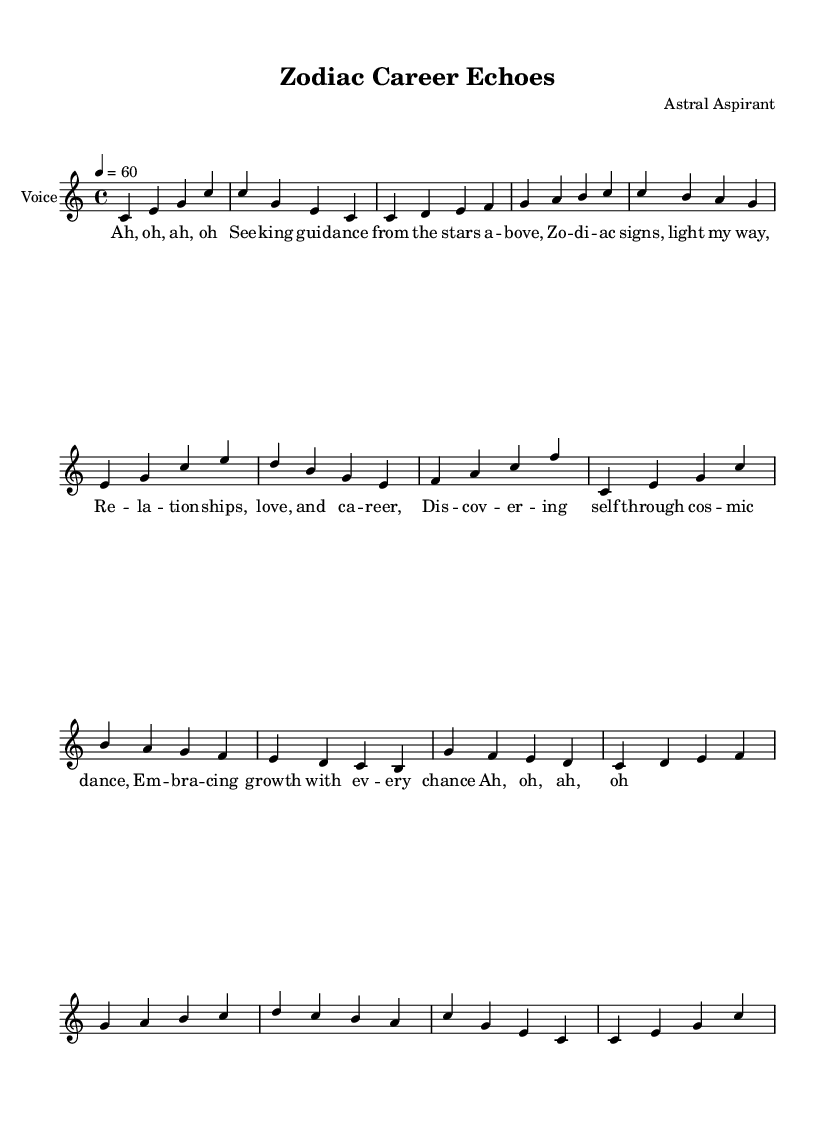What is the key signature of this music? The key signature is indicated in the global settings at the beginning of the code. It states that the piece is in C major, which is represented by no sharps or flats.
Answer: C major What is the time signature of the piece? The time signature is specified in the global settings as 4/4. This indicates that there are four beats in each measure, and the quarter note gets one beat.
Answer: 4/4 What is the tempo marking in the score? The tempo is defined in the global section as 4 = 60, which sets the speed of the music at 60 beats per minute, meaning there are 60 quarter note beats in one minute.
Answer: 60 How many measures are there in the main sections of the score? Examining the structure provided in the voice part, the main sections consist of: Introduction (2 measures), Verse 1 (4 measures), Chorus (3 measures), Verse 2 (3 measures), Bridge (4 measures), and Outro (2 measures), summing up to 18 measures.
Answer: 18 measures What emotive theme can be identified in the lyrics? The lyrics depict a theme of seeking guidance from the stars and exploring relationships and self-discovery, which align with personal growth and cosmic influences, characteristic of a reflective emotive style.
Answer: Seeking guidance How is the structure of the music characterized? The music is structured into distinct sections: Introduction, Verse, Chorus, and Outro, along with a Bridge, demonstrating traditional song form while maintaining an experimental feel.
Answer: Structured with distinct sections What vocal technique is employed in the lyrics? The lyrics feature repetitive phonetic sounds ("Ah, oh") which is common in experimental vocal loops, creating an ambient and ethereal quality to the vocal delivery.
Answer: Repetitive phonetic sounds 